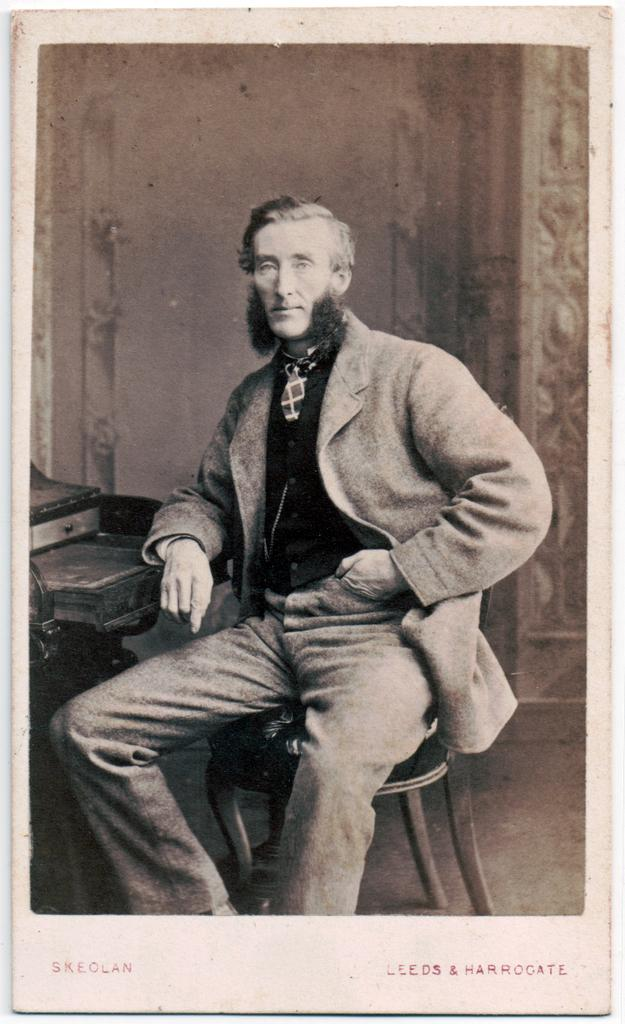What is the color scheme of the image? The image is black and white. What can be seen in the image besides the color scheme? There is a person sitting on a chair in the image. Is there any text present in the image? Yes, there is some text at the bottom of the image. What is located on the left side of the image? There is an object on the left side of the image. How many arches can be seen in the image? There are no arches present in the image. What type of headwear is the person wearing in the image? The image is black and white, and there is no indication of any headwear on the person. 